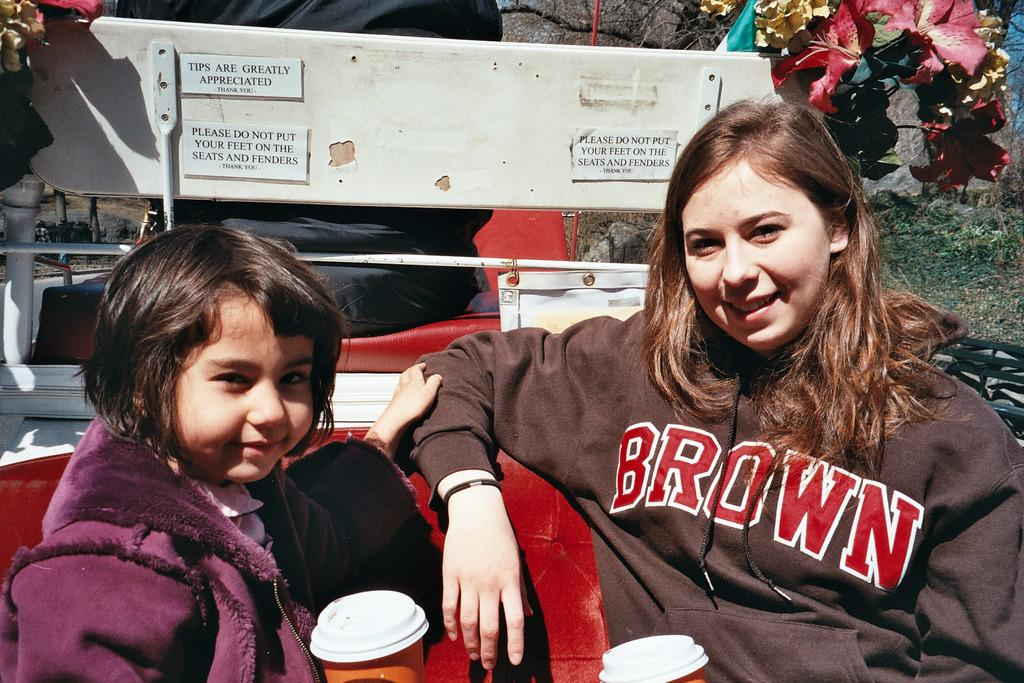<image>
Summarize the visual content of the image. Two girls, one of whom is wearing a sweater with the word Brown on it. 